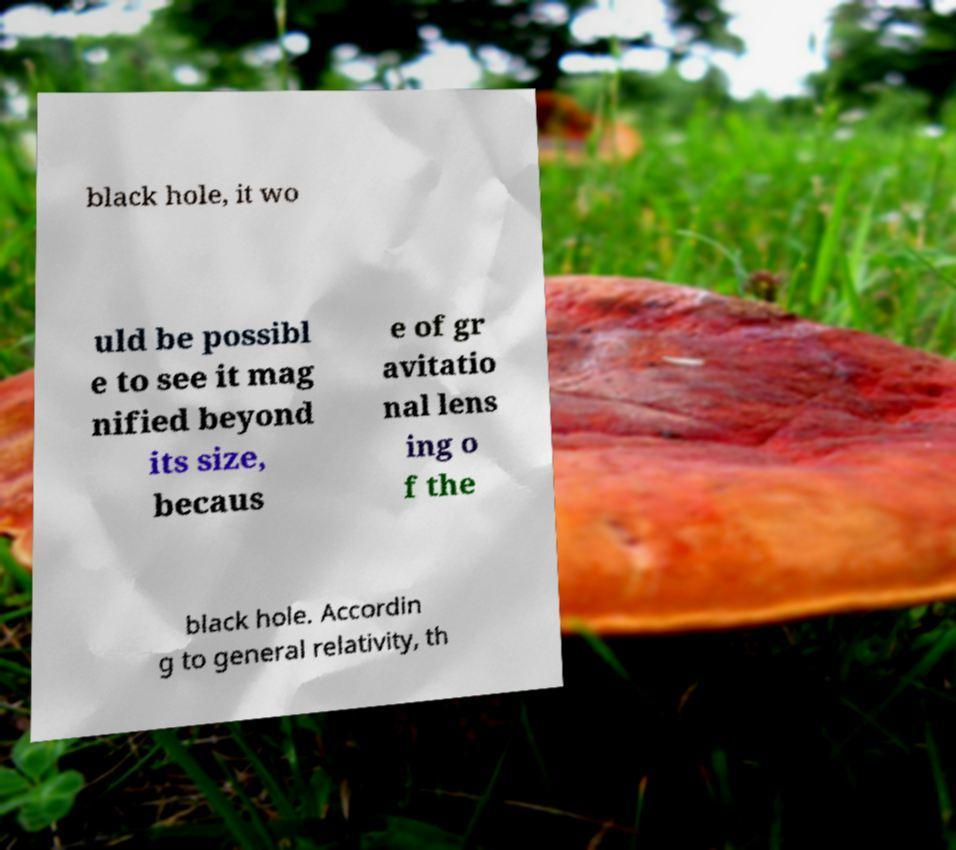For documentation purposes, I need the text within this image transcribed. Could you provide that? black hole, it wo uld be possibl e to see it mag nified beyond its size, becaus e of gr avitatio nal lens ing o f the black hole. Accordin g to general relativity, th 